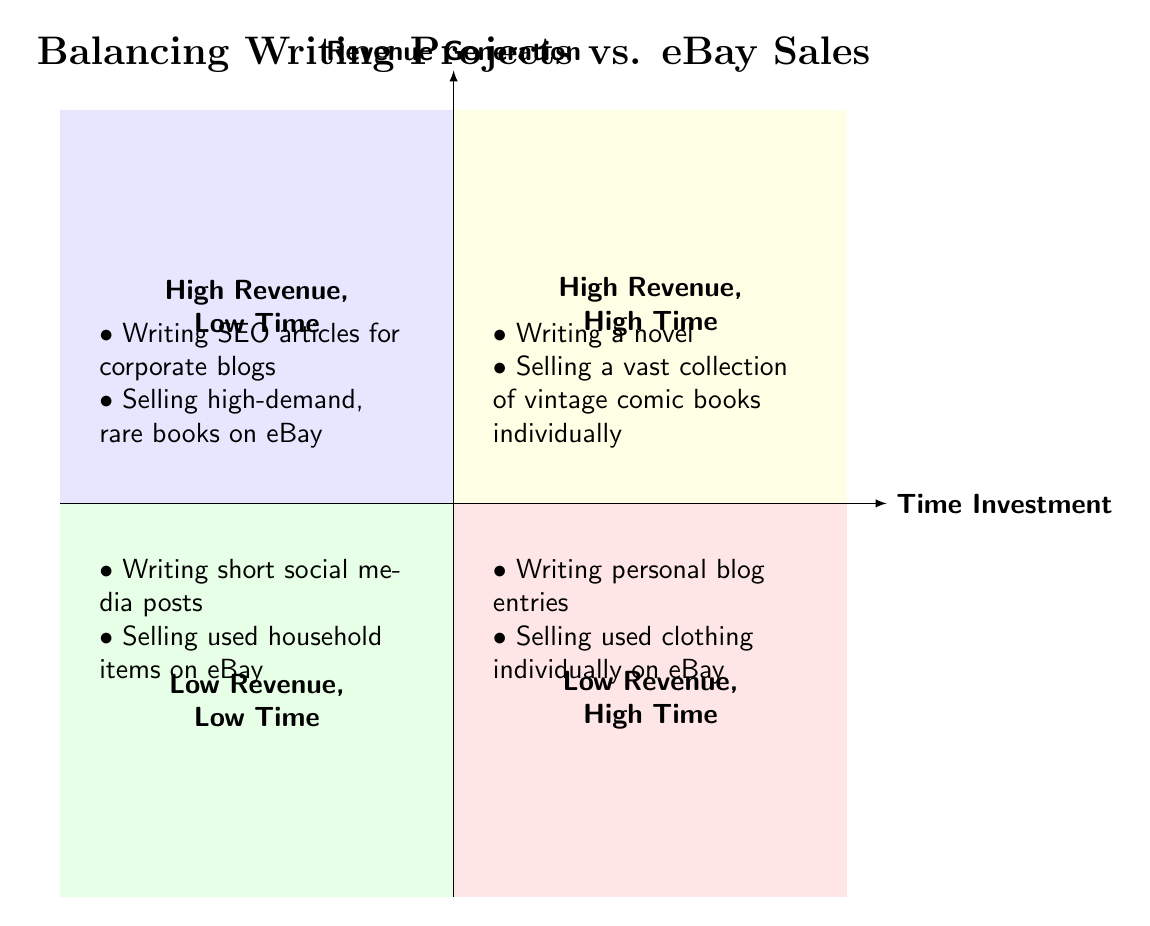What is located in the Top-Left quadrant? The Top-Left quadrant is labeled "High Revenue, Low Time," and contains the elements "Writing SEO articles for corporate blogs" and "Selling high-demand, rare books on eBay."
Answer: Writing SEO articles for corporate blogs, Selling high-demand, rare books on eBay How many elements are there in the Bottom-Right quadrant? The Bottom-Right quadrant is labeled "Low Revenue, High Time" and contains two elements: "Writing personal blog entries" and "Selling used clothing individually on eBay." Counting these gives a total of 2 elements.
Answer: 2 What are the two activities with high revenue and high time investment? The Top-Right quadrant, which is labeled "High Revenue, High Time," includes "Writing a novel" and "Selling a vast collection of vintage comic books individually."
Answer: Writing a novel, Selling a vast collection of vintage comic books individually Which quadrant contains activities with low time but also low revenue? The Bottom-Left quadrant is labeled "Low Revenue, Low Time," which includes "Writing short social media posts" and "Selling used household items on eBay."
Answer: Bottom-Left Which quadrant would you find personal blog entries categorized under? Personal blog entries are categorized in the Bottom-Right quadrant, which is labeled "Low Revenue, High Time."
Answer: Bottom-Right Identify the relationship between "Selling high-demand, rare books on eBay" and "Writing SEO articles for corporate blogs." Both activities are found in the same quadrant, which is the Top-Left quadrant labeled "High Revenue, Low Time." This indicates that they both have high revenue potential but require less time investment.
Answer: Same quadrant What is the primary axis that represents revenue generation? The vertical line in the diagram represents the revenue generation, rising from low at the bottom to high at the top.
Answer: Revenue Generation Which activity has the lowest revenue potential according to the diagram? The Bottom-Left quadrant, which is labeled "Low Revenue, Low Time," indicates that both "Writing short social media posts" and "Selling used household items on eBay" have the lowest revenue potential.
Answer: Writing short social media posts, Selling used household items on eBay 